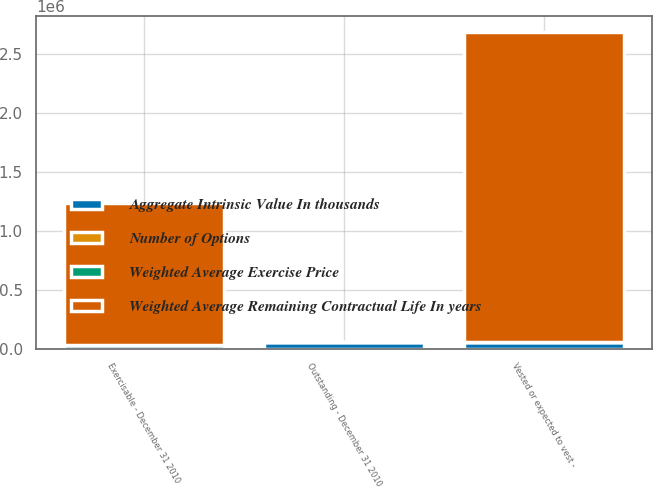Convert chart. <chart><loc_0><loc_0><loc_500><loc_500><stacked_bar_chart><ecel><fcel>Outstanding - December 31 2010<fcel>Vested or expected to vest -<fcel>Exercisable - December 31 2010<nl><fcel>Weighted Average Remaining Contractual Life In years<fcel>10.33<fcel>2.63109e+06<fcel>1.20557e+06<nl><fcel>Number of Options<fcel>10.33<fcel>9.96<fcel>6.11<nl><fcel>Weighted Average Exercise Price<fcel>6.93<fcel>4.97<fcel>5.3<nl><fcel>Aggregate Intrinsic Value In thousands<fcel>57101<fcel>56992<fcel>30946<nl></chart> 